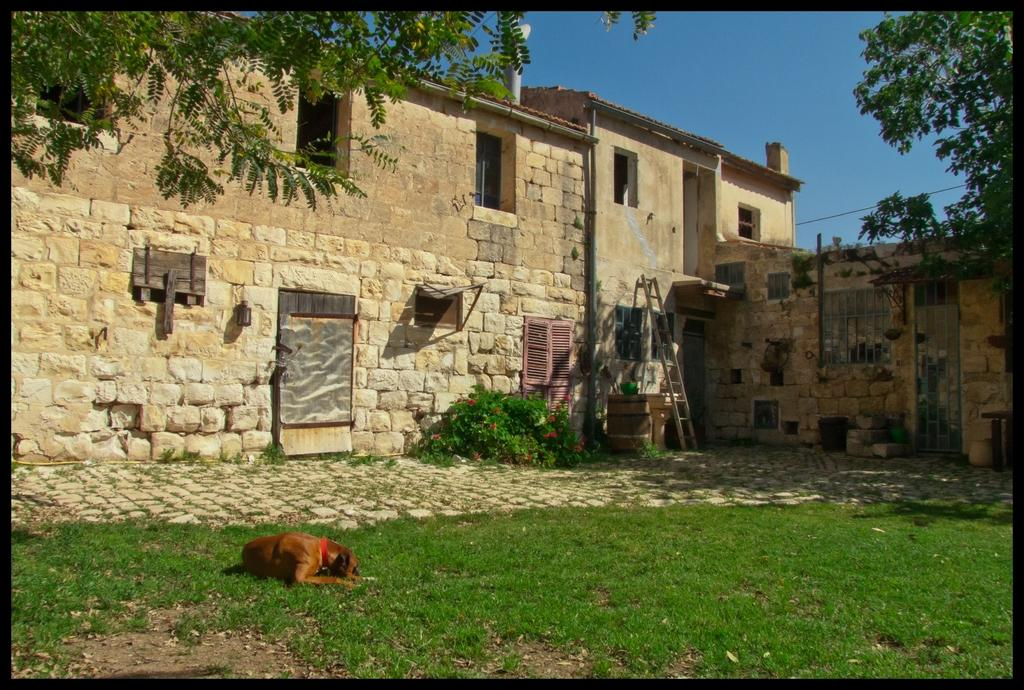What type of structures can be seen in the image? There are buildings in the image. What architectural feature is present in the image? There is a wall in the image. What can be used to enter or exit the building? There is a door in the image. What allows light and air into the building? There are windows in the image. What type of animal is present in the image? There is a dog in the image. What type of vegetation can be seen in the image? There is grass, trees, and plants in the image. What part of the natural environment is visible in the image? The sky is visible in the image. What type of tank is visible in the image? There is no tank present in the image. What type of town is depicted in the image? The image does not depict a town; it shows a building with a wall, door, windows, and surrounding vegetation. 